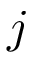Convert formula to latex. <formula><loc_0><loc_0><loc_500><loc_500>j</formula> 